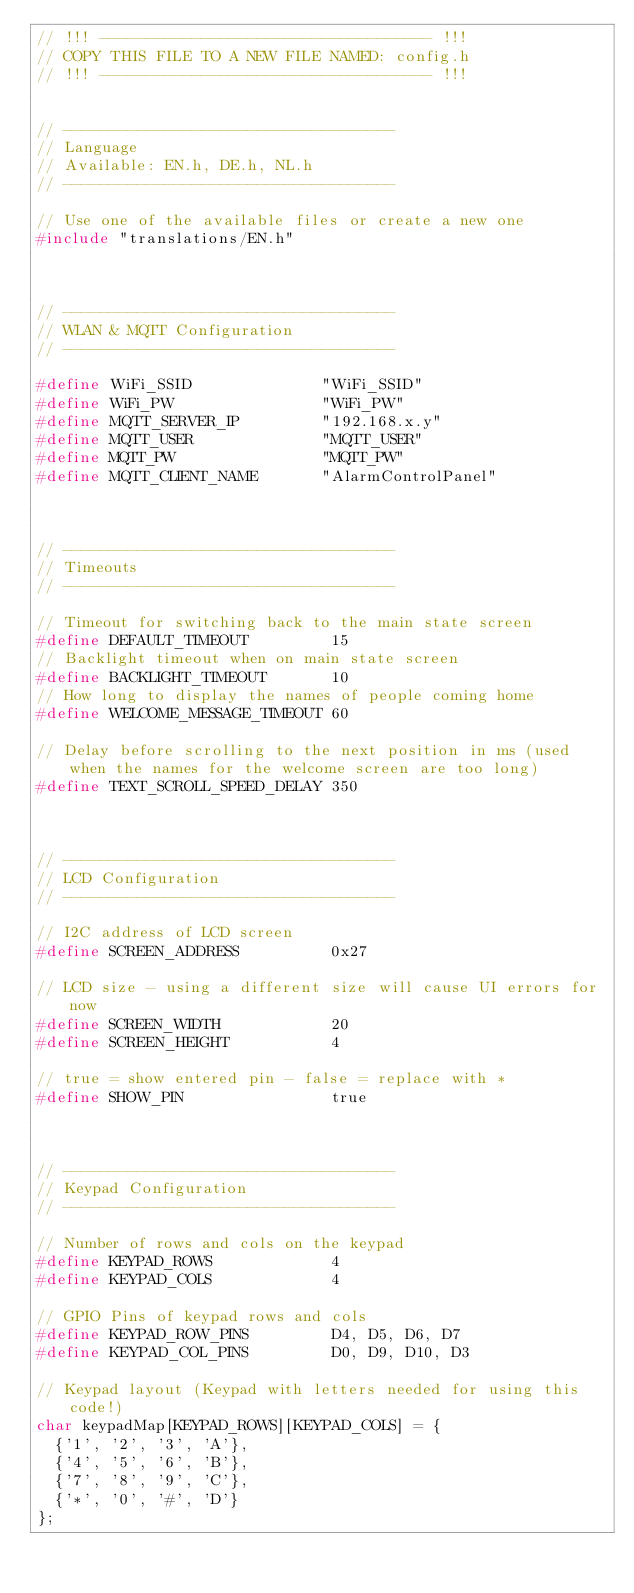Convert code to text. <code><loc_0><loc_0><loc_500><loc_500><_C_>// !!! ------------------------------------ !!!
// COPY THIS FILE TO A NEW FILE NAMED: config.h
// !!! ------------------------------------ !!!


// ------------------------------------ 
// Language
// Available: EN.h, DE.h, NL.h
// ------------------------------------ 

// Use one of the available files or create a new one
#include "translations/EN.h"



// ------------------------------------ 
// WLAN & MQTT Configuration
// ------------------------------------ 

#define WiFi_SSID              "WiFi_SSID"
#define WiFi_PW                "WiFi_PW"
#define MQTT_SERVER_IP         "192.168.x.y"
#define MQTT_USER              "MQTT_USER"
#define MQTT_PW                "MQTT_PW"
#define MQTT_CLIENT_NAME       "AlarmControlPanel"



// ------------------------------------ 
// Timeouts
// ------------------------------------ 

// Timeout for switching back to the main state screen
#define DEFAULT_TIMEOUT         15
// Backlight timeout when on main state screen
#define BACKLIGHT_TIMEOUT       10
// How long to display the names of people coming home
#define WELCOME_MESSAGE_TIMEOUT 60

// Delay before scrolling to the next position in ms (used when the names for the welcome screen are too long)
#define TEXT_SCROLL_SPEED_DELAY 350



// ------------------------------------ 
// LCD Configuration
// ------------------------------------ 

// I2C address of LCD screen
#define SCREEN_ADDRESS          0x27

// LCD size - using a different size will cause UI errors for now
#define SCREEN_WIDTH            20
#define SCREEN_HEIGHT           4

// true = show entered pin - false = replace with *
#define SHOW_PIN                true



// ------------------------------------ 
// Keypad Configuration
// ------------------------------------

// Number of rows and cols on the keypad
#define KEYPAD_ROWS             4
#define KEYPAD_COLS             4

// GPIO Pins of keypad rows and cols
#define KEYPAD_ROW_PINS         D4, D5, D6, D7
#define KEYPAD_COL_PINS         D0, D9, D10, D3

// Keypad layout (Keypad with letters needed for using this code!)
char keypadMap[KEYPAD_ROWS][KEYPAD_COLS] = {
  {'1', '2', '3', 'A'},
  {'4', '5', '6', 'B'},
  {'7', '8', '9', 'C'},
  {'*', '0', '#', 'D'}
};</code> 